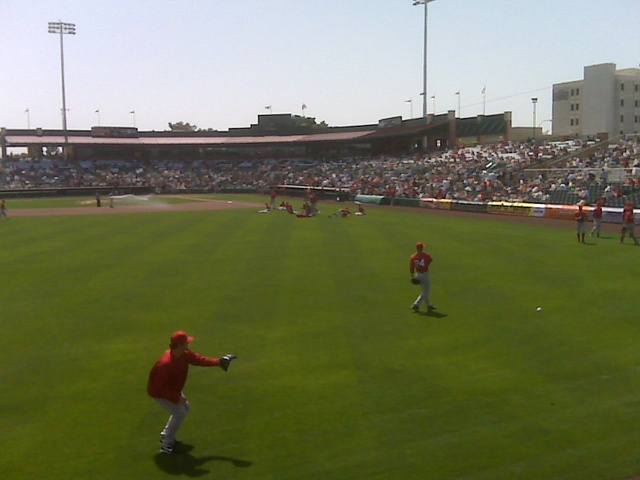Describe the objects in this image and their specific colors. I can see people in lavender, gray, darkgreen, and black tones, people in lavender, black, maroon, darkgreen, and brown tones, people in lavender, black, darkgreen, maroon, and gray tones, people in lavender, maroon, darkgreen, gray, and black tones, and people in lavender, black, maroon, and darkgreen tones in this image. 